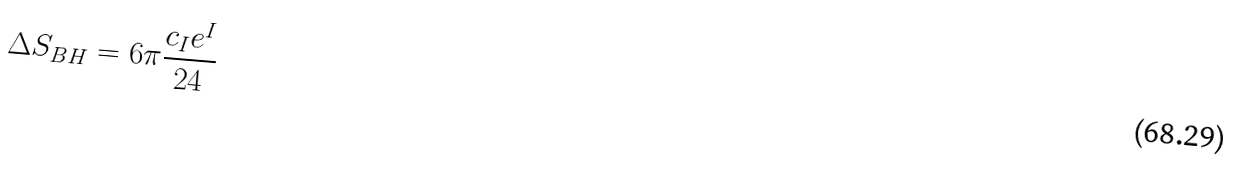<formula> <loc_0><loc_0><loc_500><loc_500>\Delta S _ { B H } = 6 \pi \frac { c _ { I } e ^ { I } } { 2 4 }</formula> 